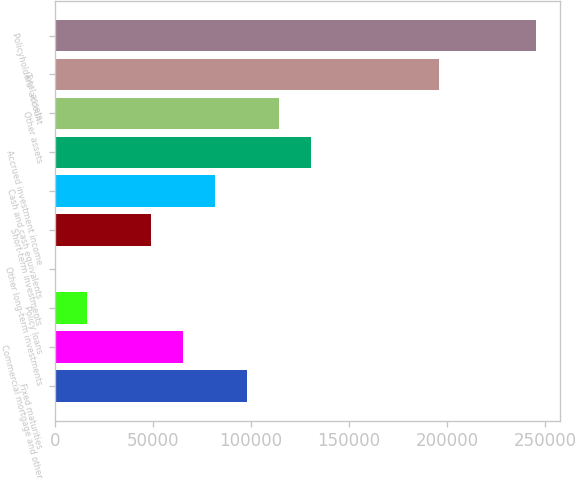Convert chart to OTSL. <chart><loc_0><loc_0><loc_500><loc_500><bar_chart><fcel>Fixed maturities<fcel>Commercial mortgage and other<fcel>Policy loans<fcel>Other long-term investments<fcel>Short-term investments<fcel>Cash and cash equivalents<fcel>Accrued investment income<fcel>Other assets<fcel>Total assets<fcel>Policyholders' account<nl><fcel>98082<fcel>65388.5<fcel>16348.2<fcel>1.47<fcel>49041.7<fcel>81735.2<fcel>130775<fcel>114429<fcel>196162<fcel>245203<nl></chart> 